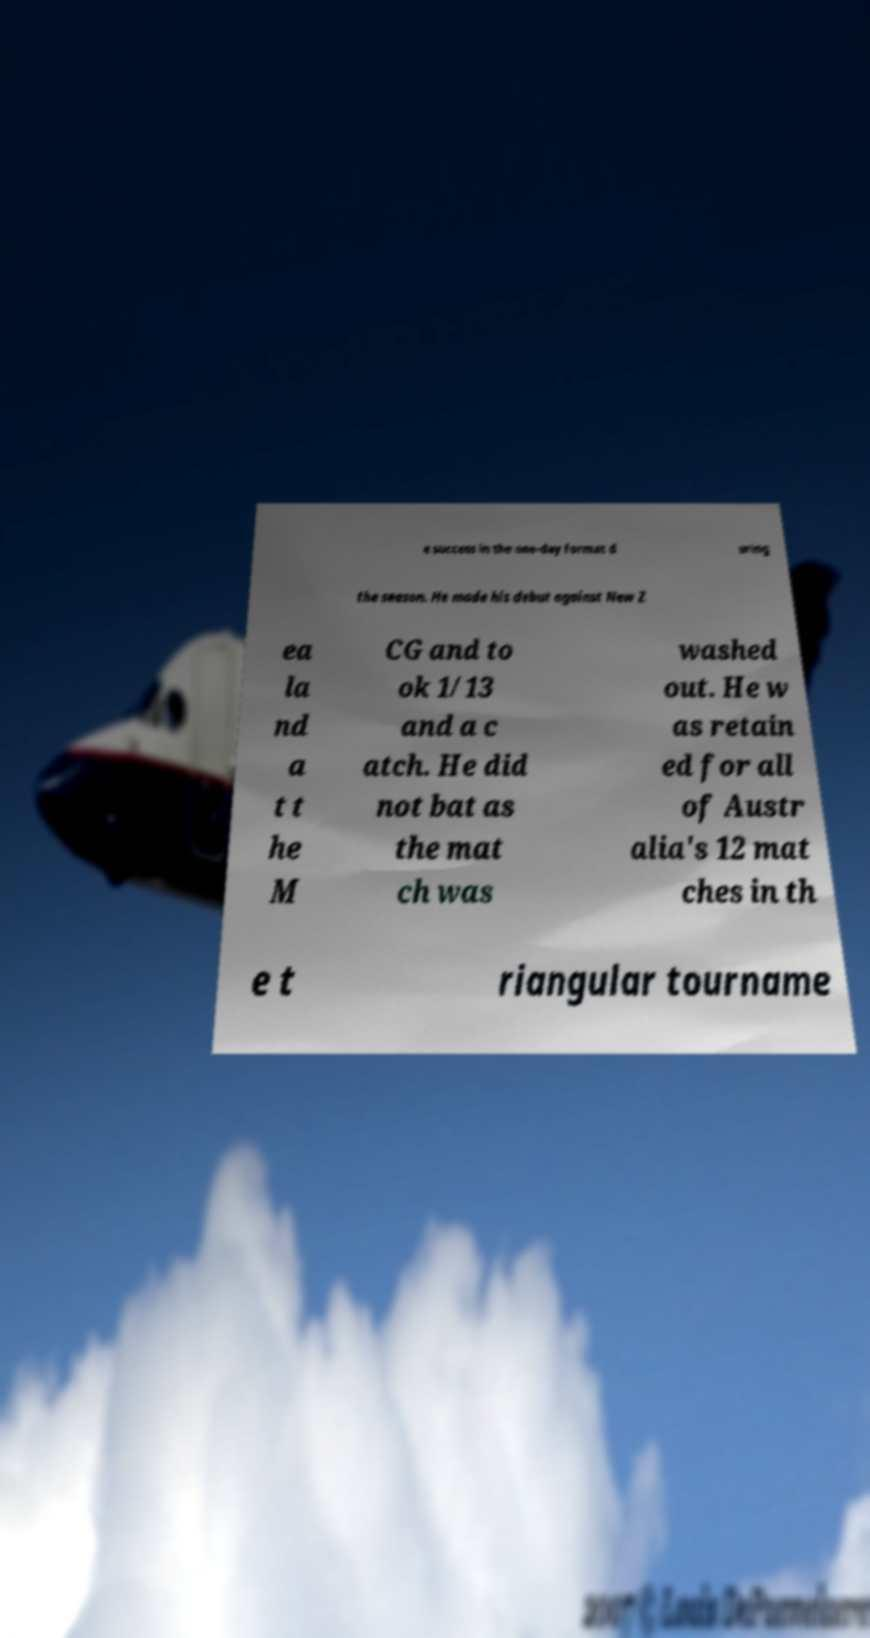I need the written content from this picture converted into text. Can you do that? e success in the one-day format d uring the season. He made his debut against New Z ea la nd a t t he M CG and to ok 1/13 and a c atch. He did not bat as the mat ch was washed out. He w as retain ed for all of Austr alia's 12 mat ches in th e t riangular tourname 